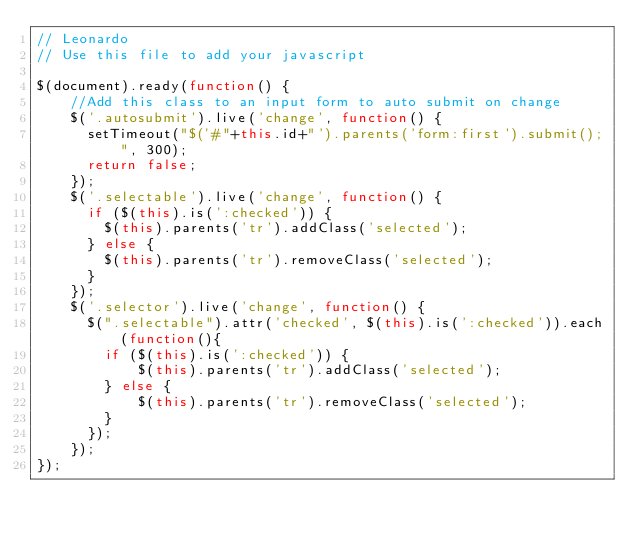Convert code to text. <code><loc_0><loc_0><loc_500><loc_500><_JavaScript_>// Leonardo
// Use this file to add your javascript

$(document).ready(function() {
    //Add this class to an input form to auto submit on change
    $('.autosubmit').live('change', function() {
      setTimeout("$('#"+this.id+"').parents('form:first').submit();", 300);
      return false;
    });
    $('.selectable').live('change', function() {
      if ($(this).is(':checked')) {
        $(this).parents('tr').addClass('selected');
      } else {
        $(this).parents('tr').removeClass('selected');
      }
    });
    $('.selector').live('change', function() {
      $(".selectable").attr('checked', $(this).is(':checked')).each(function(){
        if ($(this).is(':checked')) {
            $(this).parents('tr').addClass('selected');
        } else {
            $(this).parents('tr').removeClass('selected');
        }
      });
    });
});</code> 